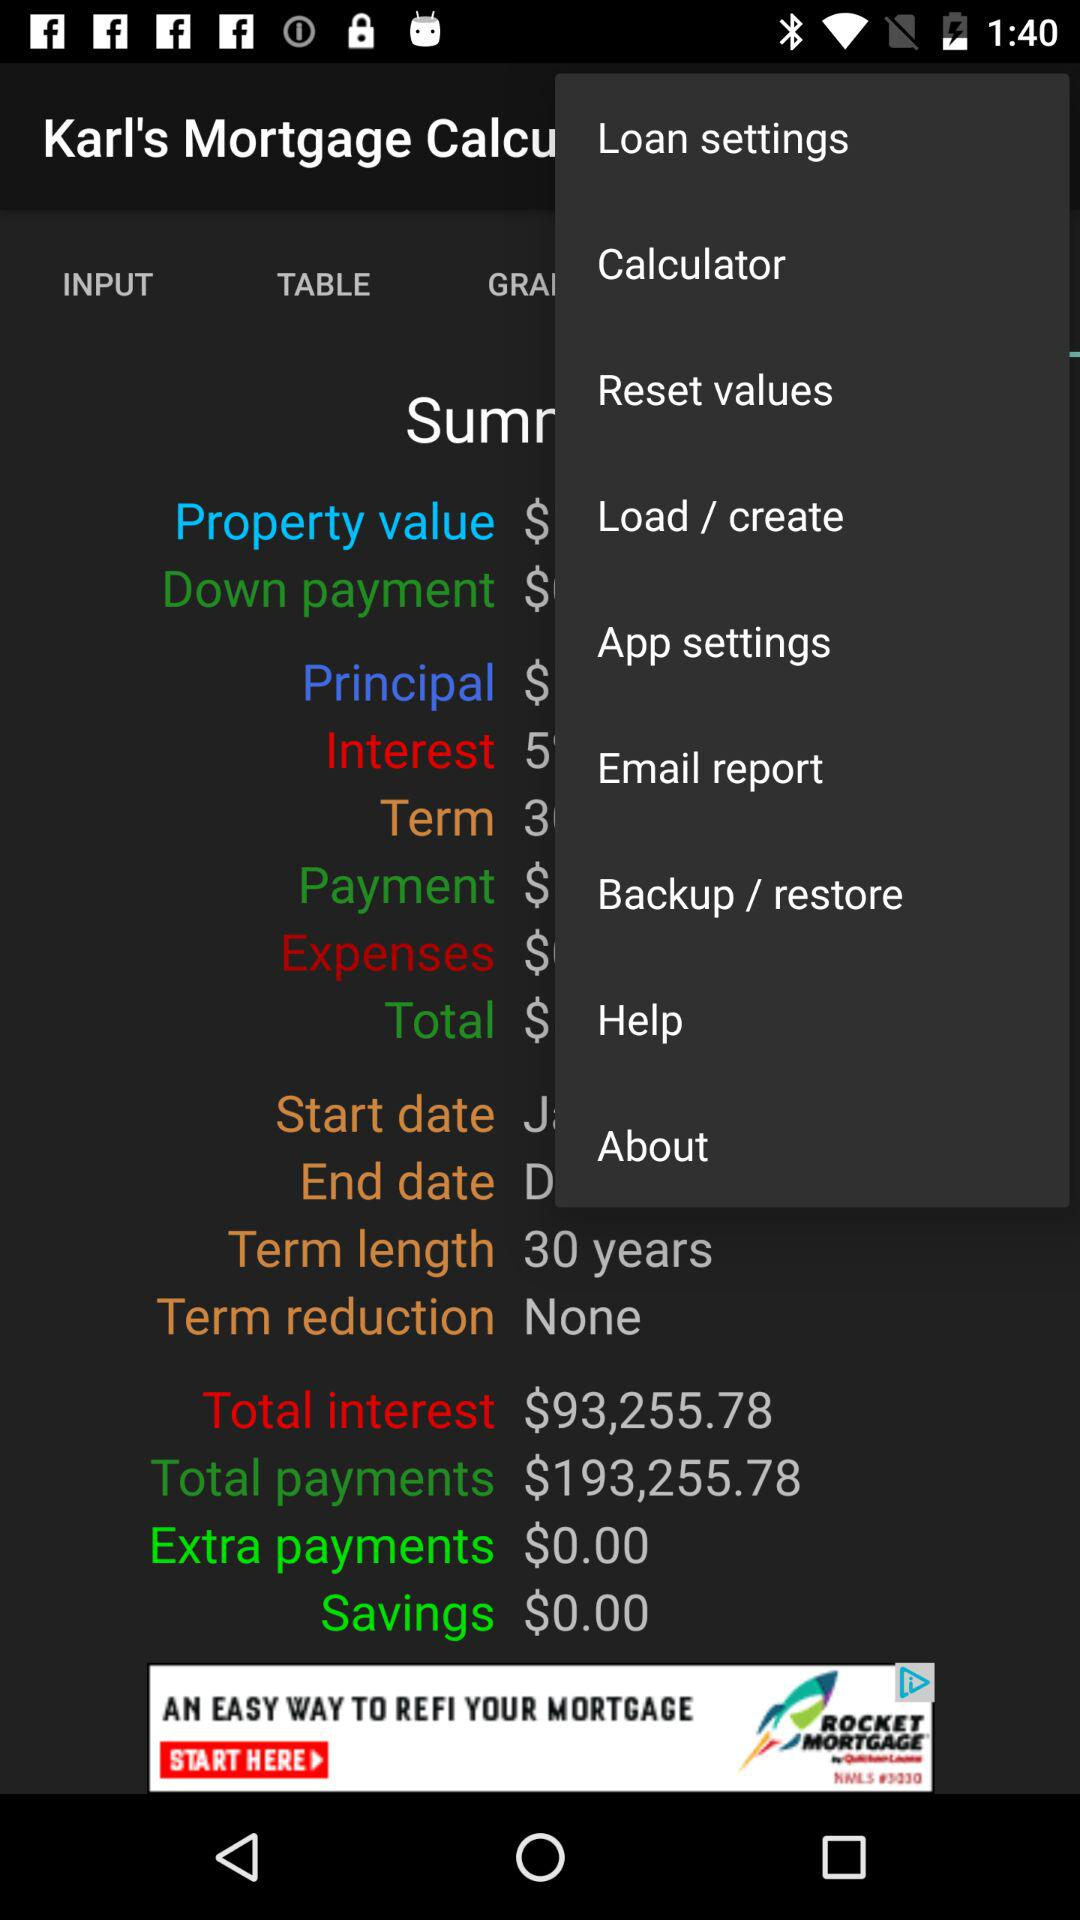What is the amount of "Total interest"? The amount is $93,255.78. 